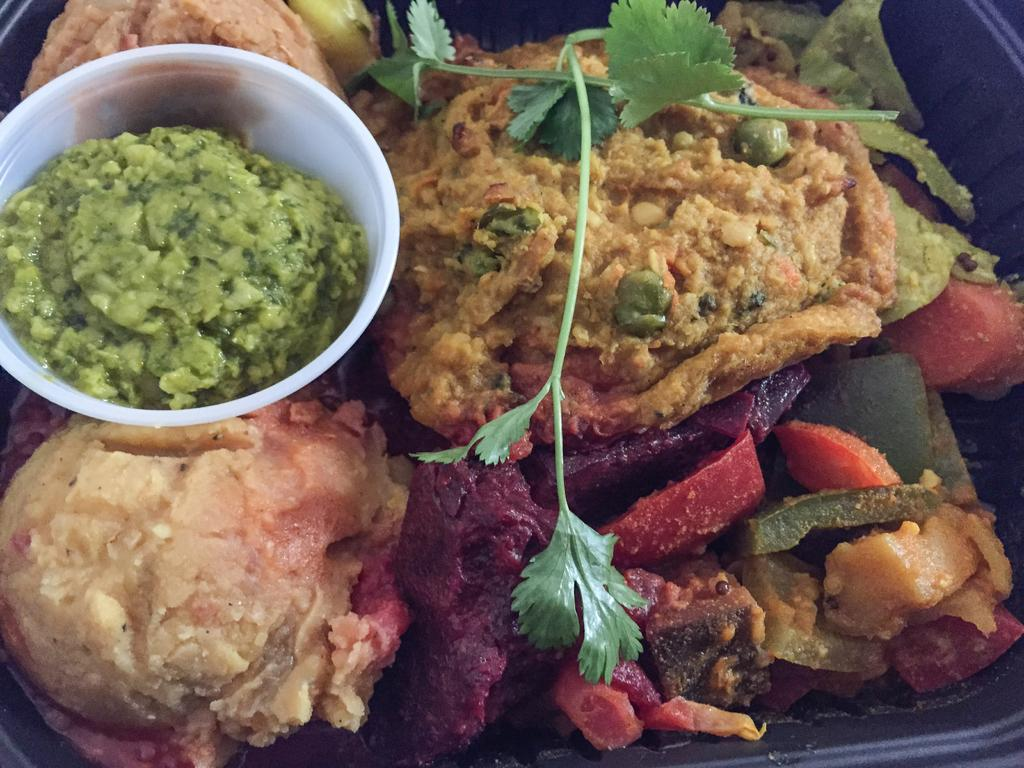What is on the plate in the image? There is a plate with different kinds of food items in the image. What else can be seen in the image besides the plate? There is a white bowl with a food item in the image. Can you describe any additional details about the food items? Coriander leaves are present on the food items. How many geese are talking to each other while wearing sweaters in the image? There are no geese or sweaters present in the image. 